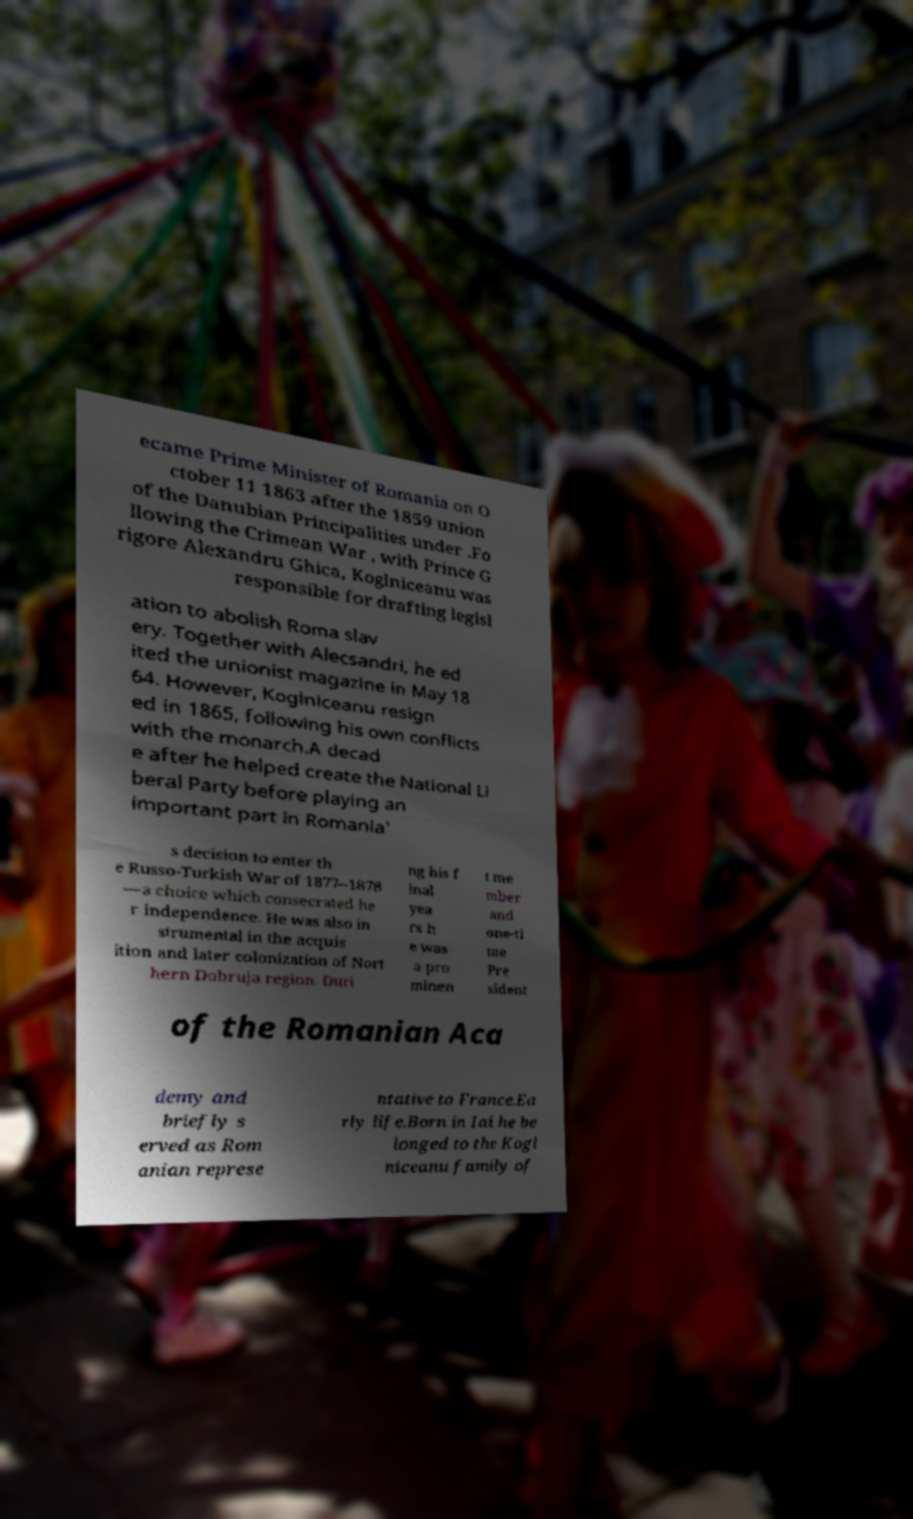Please identify and transcribe the text found in this image. ecame Prime Minister of Romania on O ctober 11 1863 after the 1859 union of the Danubian Principalities under .Fo llowing the Crimean War , with Prince G rigore Alexandru Ghica, Koglniceanu was responsible for drafting legisl ation to abolish Roma slav ery. Together with Alecsandri, he ed ited the unionist magazine in May 18 64. However, Koglniceanu resign ed in 1865, following his own conflicts with the monarch.A decad e after he helped create the National Li beral Party before playing an important part in Romania' s decision to enter th e Russo-Turkish War of 1877–1878 —a choice which consecrated he r independence. He was also in strumental in the acquis ition and later colonization of Nort hern Dobruja region. Duri ng his f inal yea rs h e was a pro minen t me mber and one-ti me Pre sident of the Romanian Aca demy and briefly s erved as Rom anian represe ntative to France.Ea rly life.Born in Iai he be longed to the Kogl niceanu family of 